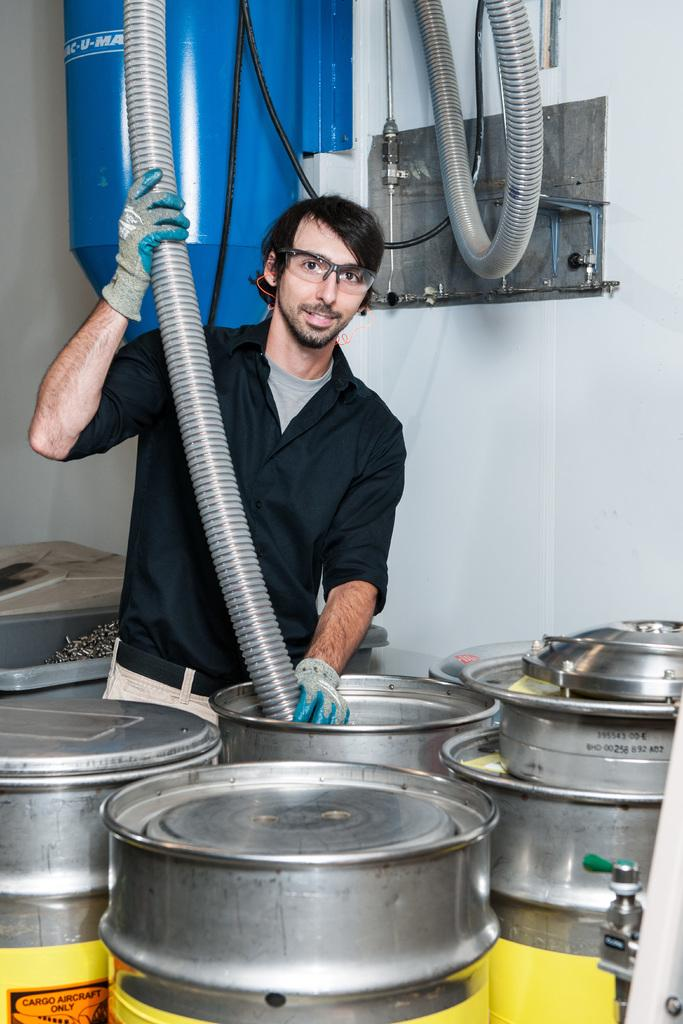Who is the main subject in the image? There is a boy in the image. Where is the boy located in the image? The boy is on the left side of the image. What is the boy holding in his hands? The boy is holding a pipe in his hands. What objects are in front of the boy? There are steel containers in front of the boy. What type of sand can be seen in the image? There is no sand present in the image. How many bees are buzzing around the boy in the image? There are no bees present in the image. 